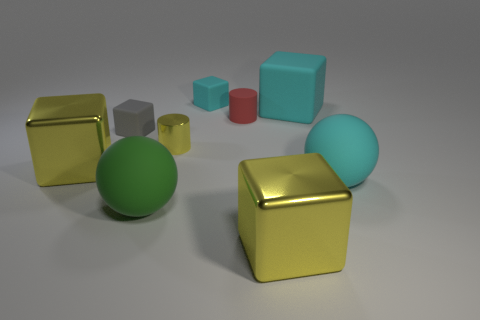What is the material of the large sphere that is the same color as the big rubber cube?
Provide a succinct answer. Rubber. Are there any cubes that have the same color as the small shiny object?
Give a very brief answer. Yes. There is a yellow object that is in front of the yellow cube that is on the left side of the green thing; what is its size?
Offer a very short reply. Large. There is a small yellow object that is the same shape as the red thing; what material is it?
Provide a short and direct response. Metal. There is a large cyan matte thing that is in front of the gray object; is its shape the same as the gray thing that is left of the tiny red rubber object?
Your answer should be very brief. No. Is the number of blocks greater than the number of objects?
Your response must be concise. No. How big is the green ball?
Keep it short and to the point. Large. How many other things are the same color as the tiny metallic object?
Your answer should be very brief. 2. Are the big yellow object on the left side of the red rubber thing and the cyan ball made of the same material?
Keep it short and to the point. No. Is the number of small cubes behind the tiny rubber cylinder less than the number of things that are to the left of the cyan matte ball?
Ensure brevity in your answer.  Yes. 